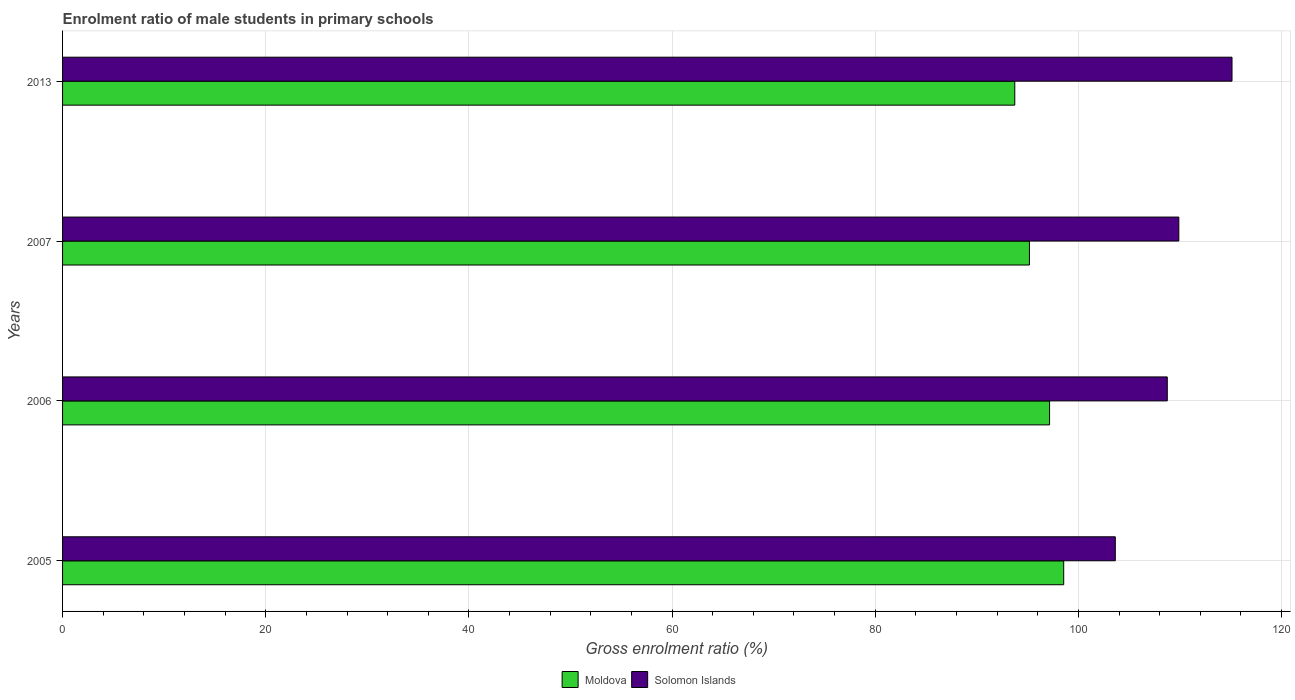Are the number of bars on each tick of the Y-axis equal?
Your response must be concise. Yes. How many bars are there on the 4th tick from the bottom?
Ensure brevity in your answer.  2. What is the label of the 2nd group of bars from the top?
Offer a very short reply. 2007. What is the enrolment ratio of male students in primary schools in Moldova in 2006?
Provide a succinct answer. 97.16. Across all years, what is the maximum enrolment ratio of male students in primary schools in Solomon Islands?
Your response must be concise. 115.12. Across all years, what is the minimum enrolment ratio of male students in primary schools in Moldova?
Your response must be concise. 93.74. In which year was the enrolment ratio of male students in primary schools in Solomon Islands maximum?
Your answer should be very brief. 2013. In which year was the enrolment ratio of male students in primary schools in Moldova minimum?
Your response must be concise. 2013. What is the total enrolment ratio of male students in primary schools in Moldova in the graph?
Offer a very short reply. 384.63. What is the difference between the enrolment ratio of male students in primary schools in Moldova in 2007 and that in 2013?
Your response must be concise. 1.44. What is the difference between the enrolment ratio of male students in primary schools in Moldova in 2006 and the enrolment ratio of male students in primary schools in Solomon Islands in 2007?
Keep it short and to the point. -12.72. What is the average enrolment ratio of male students in primary schools in Moldova per year?
Ensure brevity in your answer.  96.16. In the year 2013, what is the difference between the enrolment ratio of male students in primary schools in Moldova and enrolment ratio of male students in primary schools in Solomon Islands?
Your answer should be very brief. -21.38. In how many years, is the enrolment ratio of male students in primary schools in Solomon Islands greater than 80 %?
Give a very brief answer. 4. What is the ratio of the enrolment ratio of male students in primary schools in Moldova in 2005 to that in 2013?
Ensure brevity in your answer.  1.05. Is the enrolment ratio of male students in primary schools in Solomon Islands in 2006 less than that in 2007?
Make the answer very short. Yes. Is the difference between the enrolment ratio of male students in primary schools in Moldova in 2005 and 2013 greater than the difference between the enrolment ratio of male students in primary schools in Solomon Islands in 2005 and 2013?
Give a very brief answer. Yes. What is the difference between the highest and the second highest enrolment ratio of male students in primary schools in Solomon Islands?
Offer a very short reply. 5.24. What is the difference between the highest and the lowest enrolment ratio of male students in primary schools in Solomon Islands?
Keep it short and to the point. 11.49. In how many years, is the enrolment ratio of male students in primary schools in Moldova greater than the average enrolment ratio of male students in primary schools in Moldova taken over all years?
Offer a terse response. 2. Is the sum of the enrolment ratio of male students in primary schools in Solomon Islands in 2005 and 2007 greater than the maximum enrolment ratio of male students in primary schools in Moldova across all years?
Provide a short and direct response. Yes. What does the 2nd bar from the top in 2013 represents?
Offer a terse response. Moldova. What does the 2nd bar from the bottom in 2005 represents?
Your answer should be compact. Solomon Islands. How many bars are there?
Your answer should be very brief. 8. How many years are there in the graph?
Provide a short and direct response. 4. Does the graph contain any zero values?
Your response must be concise. No. Does the graph contain grids?
Your response must be concise. Yes. How many legend labels are there?
Keep it short and to the point. 2. What is the title of the graph?
Make the answer very short. Enrolment ratio of male students in primary schools. Does "Europe(all income levels)" appear as one of the legend labels in the graph?
Ensure brevity in your answer.  No. What is the label or title of the X-axis?
Offer a very short reply. Gross enrolment ratio (%). What is the Gross enrolment ratio (%) in Moldova in 2005?
Ensure brevity in your answer.  98.55. What is the Gross enrolment ratio (%) in Solomon Islands in 2005?
Provide a succinct answer. 103.63. What is the Gross enrolment ratio (%) of Moldova in 2006?
Your response must be concise. 97.16. What is the Gross enrolment ratio (%) of Solomon Islands in 2006?
Keep it short and to the point. 108.75. What is the Gross enrolment ratio (%) of Moldova in 2007?
Your answer should be compact. 95.18. What is the Gross enrolment ratio (%) in Solomon Islands in 2007?
Make the answer very short. 109.89. What is the Gross enrolment ratio (%) of Moldova in 2013?
Provide a short and direct response. 93.74. What is the Gross enrolment ratio (%) of Solomon Islands in 2013?
Provide a succinct answer. 115.12. Across all years, what is the maximum Gross enrolment ratio (%) of Moldova?
Offer a terse response. 98.55. Across all years, what is the maximum Gross enrolment ratio (%) of Solomon Islands?
Keep it short and to the point. 115.12. Across all years, what is the minimum Gross enrolment ratio (%) in Moldova?
Your answer should be compact. 93.74. Across all years, what is the minimum Gross enrolment ratio (%) of Solomon Islands?
Provide a short and direct response. 103.63. What is the total Gross enrolment ratio (%) of Moldova in the graph?
Ensure brevity in your answer.  384.63. What is the total Gross enrolment ratio (%) of Solomon Islands in the graph?
Ensure brevity in your answer.  437.39. What is the difference between the Gross enrolment ratio (%) in Moldova in 2005 and that in 2006?
Your answer should be very brief. 1.39. What is the difference between the Gross enrolment ratio (%) in Solomon Islands in 2005 and that in 2006?
Offer a terse response. -5.12. What is the difference between the Gross enrolment ratio (%) of Moldova in 2005 and that in 2007?
Offer a very short reply. 3.37. What is the difference between the Gross enrolment ratio (%) in Solomon Islands in 2005 and that in 2007?
Make the answer very short. -6.25. What is the difference between the Gross enrolment ratio (%) in Moldova in 2005 and that in 2013?
Make the answer very short. 4.82. What is the difference between the Gross enrolment ratio (%) in Solomon Islands in 2005 and that in 2013?
Make the answer very short. -11.49. What is the difference between the Gross enrolment ratio (%) in Moldova in 2006 and that in 2007?
Provide a succinct answer. 1.98. What is the difference between the Gross enrolment ratio (%) of Solomon Islands in 2006 and that in 2007?
Offer a terse response. -1.14. What is the difference between the Gross enrolment ratio (%) in Moldova in 2006 and that in 2013?
Make the answer very short. 3.42. What is the difference between the Gross enrolment ratio (%) of Solomon Islands in 2006 and that in 2013?
Offer a very short reply. -6.37. What is the difference between the Gross enrolment ratio (%) of Moldova in 2007 and that in 2013?
Provide a succinct answer. 1.44. What is the difference between the Gross enrolment ratio (%) of Solomon Islands in 2007 and that in 2013?
Your answer should be very brief. -5.24. What is the difference between the Gross enrolment ratio (%) in Moldova in 2005 and the Gross enrolment ratio (%) in Solomon Islands in 2006?
Make the answer very short. -10.2. What is the difference between the Gross enrolment ratio (%) in Moldova in 2005 and the Gross enrolment ratio (%) in Solomon Islands in 2007?
Provide a short and direct response. -11.33. What is the difference between the Gross enrolment ratio (%) in Moldova in 2005 and the Gross enrolment ratio (%) in Solomon Islands in 2013?
Make the answer very short. -16.57. What is the difference between the Gross enrolment ratio (%) in Moldova in 2006 and the Gross enrolment ratio (%) in Solomon Islands in 2007?
Offer a very short reply. -12.72. What is the difference between the Gross enrolment ratio (%) in Moldova in 2006 and the Gross enrolment ratio (%) in Solomon Islands in 2013?
Provide a succinct answer. -17.96. What is the difference between the Gross enrolment ratio (%) of Moldova in 2007 and the Gross enrolment ratio (%) of Solomon Islands in 2013?
Your answer should be compact. -19.94. What is the average Gross enrolment ratio (%) in Moldova per year?
Your answer should be very brief. 96.16. What is the average Gross enrolment ratio (%) in Solomon Islands per year?
Your answer should be compact. 109.35. In the year 2005, what is the difference between the Gross enrolment ratio (%) in Moldova and Gross enrolment ratio (%) in Solomon Islands?
Make the answer very short. -5.08. In the year 2006, what is the difference between the Gross enrolment ratio (%) in Moldova and Gross enrolment ratio (%) in Solomon Islands?
Ensure brevity in your answer.  -11.59. In the year 2007, what is the difference between the Gross enrolment ratio (%) of Moldova and Gross enrolment ratio (%) of Solomon Islands?
Ensure brevity in your answer.  -14.71. In the year 2013, what is the difference between the Gross enrolment ratio (%) in Moldova and Gross enrolment ratio (%) in Solomon Islands?
Give a very brief answer. -21.38. What is the ratio of the Gross enrolment ratio (%) of Moldova in 2005 to that in 2006?
Provide a short and direct response. 1.01. What is the ratio of the Gross enrolment ratio (%) of Solomon Islands in 2005 to that in 2006?
Provide a succinct answer. 0.95. What is the ratio of the Gross enrolment ratio (%) of Moldova in 2005 to that in 2007?
Provide a succinct answer. 1.04. What is the ratio of the Gross enrolment ratio (%) of Solomon Islands in 2005 to that in 2007?
Give a very brief answer. 0.94. What is the ratio of the Gross enrolment ratio (%) of Moldova in 2005 to that in 2013?
Your answer should be compact. 1.05. What is the ratio of the Gross enrolment ratio (%) of Solomon Islands in 2005 to that in 2013?
Offer a terse response. 0.9. What is the ratio of the Gross enrolment ratio (%) in Moldova in 2006 to that in 2007?
Give a very brief answer. 1.02. What is the ratio of the Gross enrolment ratio (%) in Moldova in 2006 to that in 2013?
Keep it short and to the point. 1.04. What is the ratio of the Gross enrolment ratio (%) of Solomon Islands in 2006 to that in 2013?
Provide a short and direct response. 0.94. What is the ratio of the Gross enrolment ratio (%) in Moldova in 2007 to that in 2013?
Offer a terse response. 1.02. What is the ratio of the Gross enrolment ratio (%) of Solomon Islands in 2007 to that in 2013?
Provide a short and direct response. 0.95. What is the difference between the highest and the second highest Gross enrolment ratio (%) of Moldova?
Provide a succinct answer. 1.39. What is the difference between the highest and the second highest Gross enrolment ratio (%) of Solomon Islands?
Give a very brief answer. 5.24. What is the difference between the highest and the lowest Gross enrolment ratio (%) of Moldova?
Provide a succinct answer. 4.82. What is the difference between the highest and the lowest Gross enrolment ratio (%) in Solomon Islands?
Your answer should be compact. 11.49. 